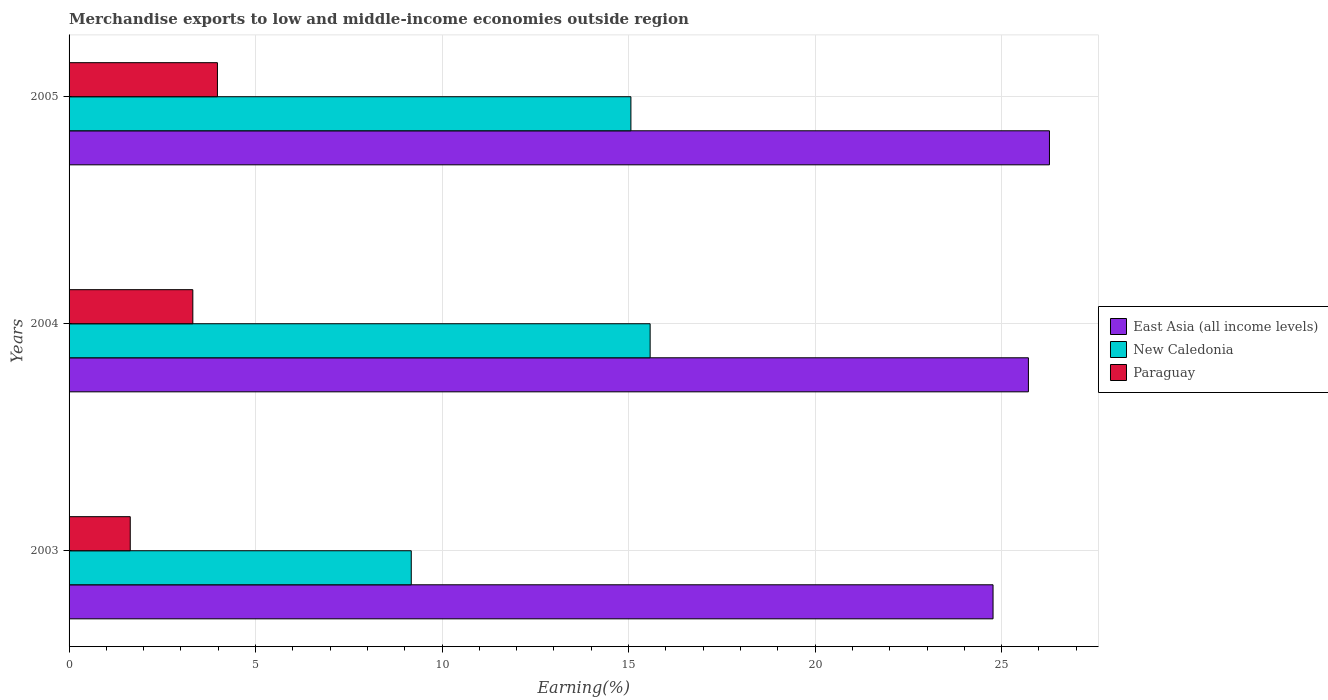How many different coloured bars are there?
Keep it short and to the point. 3. How many groups of bars are there?
Offer a terse response. 3. Are the number of bars per tick equal to the number of legend labels?
Ensure brevity in your answer.  Yes. Are the number of bars on each tick of the Y-axis equal?
Keep it short and to the point. Yes. In how many cases, is the number of bars for a given year not equal to the number of legend labels?
Your answer should be compact. 0. What is the percentage of amount earned from merchandise exports in East Asia (all income levels) in 2004?
Your answer should be compact. 25.72. Across all years, what is the maximum percentage of amount earned from merchandise exports in Paraguay?
Make the answer very short. 3.98. Across all years, what is the minimum percentage of amount earned from merchandise exports in East Asia (all income levels)?
Provide a succinct answer. 24.77. In which year was the percentage of amount earned from merchandise exports in East Asia (all income levels) minimum?
Give a very brief answer. 2003. What is the total percentage of amount earned from merchandise exports in Paraguay in the graph?
Keep it short and to the point. 8.94. What is the difference between the percentage of amount earned from merchandise exports in Paraguay in 2003 and that in 2004?
Provide a short and direct response. -1.68. What is the difference between the percentage of amount earned from merchandise exports in Paraguay in 2005 and the percentage of amount earned from merchandise exports in East Asia (all income levels) in 2003?
Offer a very short reply. -20.79. What is the average percentage of amount earned from merchandise exports in East Asia (all income levels) per year?
Offer a very short reply. 25.59. In the year 2004, what is the difference between the percentage of amount earned from merchandise exports in New Caledonia and percentage of amount earned from merchandise exports in Paraguay?
Provide a short and direct response. 12.26. What is the ratio of the percentage of amount earned from merchandise exports in Paraguay in 2003 to that in 2005?
Your answer should be very brief. 0.41. Is the percentage of amount earned from merchandise exports in East Asia (all income levels) in 2003 less than that in 2005?
Your response must be concise. Yes. What is the difference between the highest and the second highest percentage of amount earned from merchandise exports in East Asia (all income levels)?
Make the answer very short. 0.56. What is the difference between the highest and the lowest percentage of amount earned from merchandise exports in Paraguay?
Provide a succinct answer. 2.34. Is the sum of the percentage of amount earned from merchandise exports in Paraguay in 2003 and 2004 greater than the maximum percentage of amount earned from merchandise exports in East Asia (all income levels) across all years?
Keep it short and to the point. No. What does the 2nd bar from the top in 2003 represents?
Provide a short and direct response. New Caledonia. What does the 1st bar from the bottom in 2004 represents?
Offer a very short reply. East Asia (all income levels). Is it the case that in every year, the sum of the percentage of amount earned from merchandise exports in East Asia (all income levels) and percentage of amount earned from merchandise exports in Paraguay is greater than the percentage of amount earned from merchandise exports in New Caledonia?
Give a very brief answer. Yes. Are all the bars in the graph horizontal?
Keep it short and to the point. Yes. How many years are there in the graph?
Your answer should be very brief. 3. Are the values on the major ticks of X-axis written in scientific E-notation?
Provide a short and direct response. No. Does the graph contain any zero values?
Your answer should be very brief. No. Does the graph contain grids?
Provide a succinct answer. Yes. Where does the legend appear in the graph?
Offer a terse response. Center right. What is the title of the graph?
Your answer should be very brief. Merchandise exports to low and middle-income economies outside region. Does "Seychelles" appear as one of the legend labels in the graph?
Keep it short and to the point. No. What is the label or title of the X-axis?
Provide a succinct answer. Earning(%). What is the Earning(%) in East Asia (all income levels) in 2003?
Offer a very short reply. 24.77. What is the Earning(%) of New Caledonia in 2003?
Keep it short and to the point. 9.17. What is the Earning(%) of Paraguay in 2003?
Offer a very short reply. 1.64. What is the Earning(%) in East Asia (all income levels) in 2004?
Your response must be concise. 25.72. What is the Earning(%) in New Caledonia in 2004?
Your response must be concise. 15.58. What is the Earning(%) in Paraguay in 2004?
Your answer should be very brief. 3.32. What is the Earning(%) of East Asia (all income levels) in 2005?
Provide a succinct answer. 26.28. What is the Earning(%) of New Caledonia in 2005?
Give a very brief answer. 15.06. What is the Earning(%) of Paraguay in 2005?
Your answer should be compact. 3.98. Across all years, what is the maximum Earning(%) in East Asia (all income levels)?
Your answer should be compact. 26.28. Across all years, what is the maximum Earning(%) in New Caledonia?
Keep it short and to the point. 15.58. Across all years, what is the maximum Earning(%) in Paraguay?
Give a very brief answer. 3.98. Across all years, what is the minimum Earning(%) of East Asia (all income levels)?
Offer a terse response. 24.77. Across all years, what is the minimum Earning(%) in New Caledonia?
Offer a terse response. 9.17. Across all years, what is the minimum Earning(%) in Paraguay?
Your answer should be very brief. 1.64. What is the total Earning(%) in East Asia (all income levels) in the graph?
Provide a short and direct response. 76.77. What is the total Earning(%) in New Caledonia in the graph?
Offer a very short reply. 39.81. What is the total Earning(%) in Paraguay in the graph?
Offer a terse response. 8.94. What is the difference between the Earning(%) in East Asia (all income levels) in 2003 and that in 2004?
Your response must be concise. -0.95. What is the difference between the Earning(%) in New Caledonia in 2003 and that in 2004?
Provide a succinct answer. -6.4. What is the difference between the Earning(%) of Paraguay in 2003 and that in 2004?
Provide a succinct answer. -1.68. What is the difference between the Earning(%) of East Asia (all income levels) in 2003 and that in 2005?
Your answer should be very brief. -1.51. What is the difference between the Earning(%) of New Caledonia in 2003 and that in 2005?
Your answer should be compact. -5.89. What is the difference between the Earning(%) of Paraguay in 2003 and that in 2005?
Provide a succinct answer. -2.34. What is the difference between the Earning(%) in East Asia (all income levels) in 2004 and that in 2005?
Give a very brief answer. -0.56. What is the difference between the Earning(%) in New Caledonia in 2004 and that in 2005?
Offer a very short reply. 0.52. What is the difference between the Earning(%) in Paraguay in 2004 and that in 2005?
Your response must be concise. -0.66. What is the difference between the Earning(%) of East Asia (all income levels) in 2003 and the Earning(%) of New Caledonia in 2004?
Provide a short and direct response. 9.19. What is the difference between the Earning(%) in East Asia (all income levels) in 2003 and the Earning(%) in Paraguay in 2004?
Make the answer very short. 21.45. What is the difference between the Earning(%) of New Caledonia in 2003 and the Earning(%) of Paraguay in 2004?
Offer a very short reply. 5.86. What is the difference between the Earning(%) in East Asia (all income levels) in 2003 and the Earning(%) in New Caledonia in 2005?
Offer a very short reply. 9.71. What is the difference between the Earning(%) in East Asia (all income levels) in 2003 and the Earning(%) in Paraguay in 2005?
Your response must be concise. 20.79. What is the difference between the Earning(%) in New Caledonia in 2003 and the Earning(%) in Paraguay in 2005?
Provide a succinct answer. 5.2. What is the difference between the Earning(%) of East Asia (all income levels) in 2004 and the Earning(%) of New Caledonia in 2005?
Make the answer very short. 10.66. What is the difference between the Earning(%) in East Asia (all income levels) in 2004 and the Earning(%) in Paraguay in 2005?
Your response must be concise. 21.74. What is the difference between the Earning(%) of New Caledonia in 2004 and the Earning(%) of Paraguay in 2005?
Your answer should be very brief. 11.6. What is the average Earning(%) in East Asia (all income levels) per year?
Give a very brief answer. 25.59. What is the average Earning(%) of New Caledonia per year?
Keep it short and to the point. 13.27. What is the average Earning(%) of Paraguay per year?
Make the answer very short. 2.98. In the year 2003, what is the difference between the Earning(%) of East Asia (all income levels) and Earning(%) of New Caledonia?
Provide a short and direct response. 15.6. In the year 2003, what is the difference between the Earning(%) in East Asia (all income levels) and Earning(%) in Paraguay?
Your response must be concise. 23.13. In the year 2003, what is the difference between the Earning(%) in New Caledonia and Earning(%) in Paraguay?
Your response must be concise. 7.53. In the year 2004, what is the difference between the Earning(%) of East Asia (all income levels) and Earning(%) of New Caledonia?
Keep it short and to the point. 10.14. In the year 2004, what is the difference between the Earning(%) in East Asia (all income levels) and Earning(%) in Paraguay?
Give a very brief answer. 22.4. In the year 2004, what is the difference between the Earning(%) of New Caledonia and Earning(%) of Paraguay?
Make the answer very short. 12.26. In the year 2005, what is the difference between the Earning(%) in East Asia (all income levels) and Earning(%) in New Caledonia?
Ensure brevity in your answer.  11.22. In the year 2005, what is the difference between the Earning(%) in East Asia (all income levels) and Earning(%) in Paraguay?
Provide a succinct answer. 22.3. In the year 2005, what is the difference between the Earning(%) in New Caledonia and Earning(%) in Paraguay?
Offer a very short reply. 11.08. What is the ratio of the Earning(%) of East Asia (all income levels) in 2003 to that in 2004?
Your answer should be very brief. 0.96. What is the ratio of the Earning(%) in New Caledonia in 2003 to that in 2004?
Provide a succinct answer. 0.59. What is the ratio of the Earning(%) in Paraguay in 2003 to that in 2004?
Offer a very short reply. 0.49. What is the ratio of the Earning(%) in East Asia (all income levels) in 2003 to that in 2005?
Your answer should be compact. 0.94. What is the ratio of the Earning(%) of New Caledonia in 2003 to that in 2005?
Your answer should be compact. 0.61. What is the ratio of the Earning(%) of Paraguay in 2003 to that in 2005?
Ensure brevity in your answer.  0.41. What is the ratio of the Earning(%) in East Asia (all income levels) in 2004 to that in 2005?
Provide a short and direct response. 0.98. What is the ratio of the Earning(%) of New Caledonia in 2004 to that in 2005?
Offer a very short reply. 1.03. What is the ratio of the Earning(%) of Paraguay in 2004 to that in 2005?
Ensure brevity in your answer.  0.83. What is the difference between the highest and the second highest Earning(%) in East Asia (all income levels)?
Ensure brevity in your answer.  0.56. What is the difference between the highest and the second highest Earning(%) in New Caledonia?
Your answer should be compact. 0.52. What is the difference between the highest and the second highest Earning(%) of Paraguay?
Provide a succinct answer. 0.66. What is the difference between the highest and the lowest Earning(%) in East Asia (all income levels)?
Ensure brevity in your answer.  1.51. What is the difference between the highest and the lowest Earning(%) in New Caledonia?
Keep it short and to the point. 6.4. What is the difference between the highest and the lowest Earning(%) of Paraguay?
Make the answer very short. 2.34. 